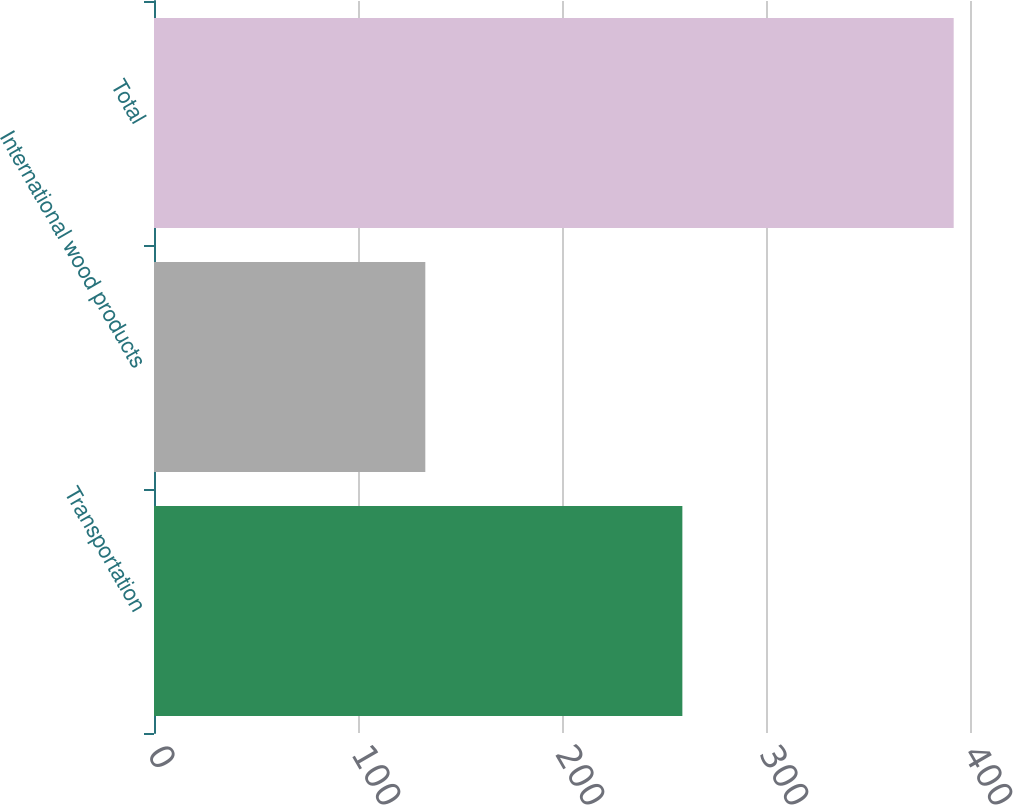<chart> <loc_0><loc_0><loc_500><loc_500><bar_chart><fcel>Transportation<fcel>International wood products<fcel>Total<nl><fcel>259<fcel>133<fcel>392<nl></chart> 